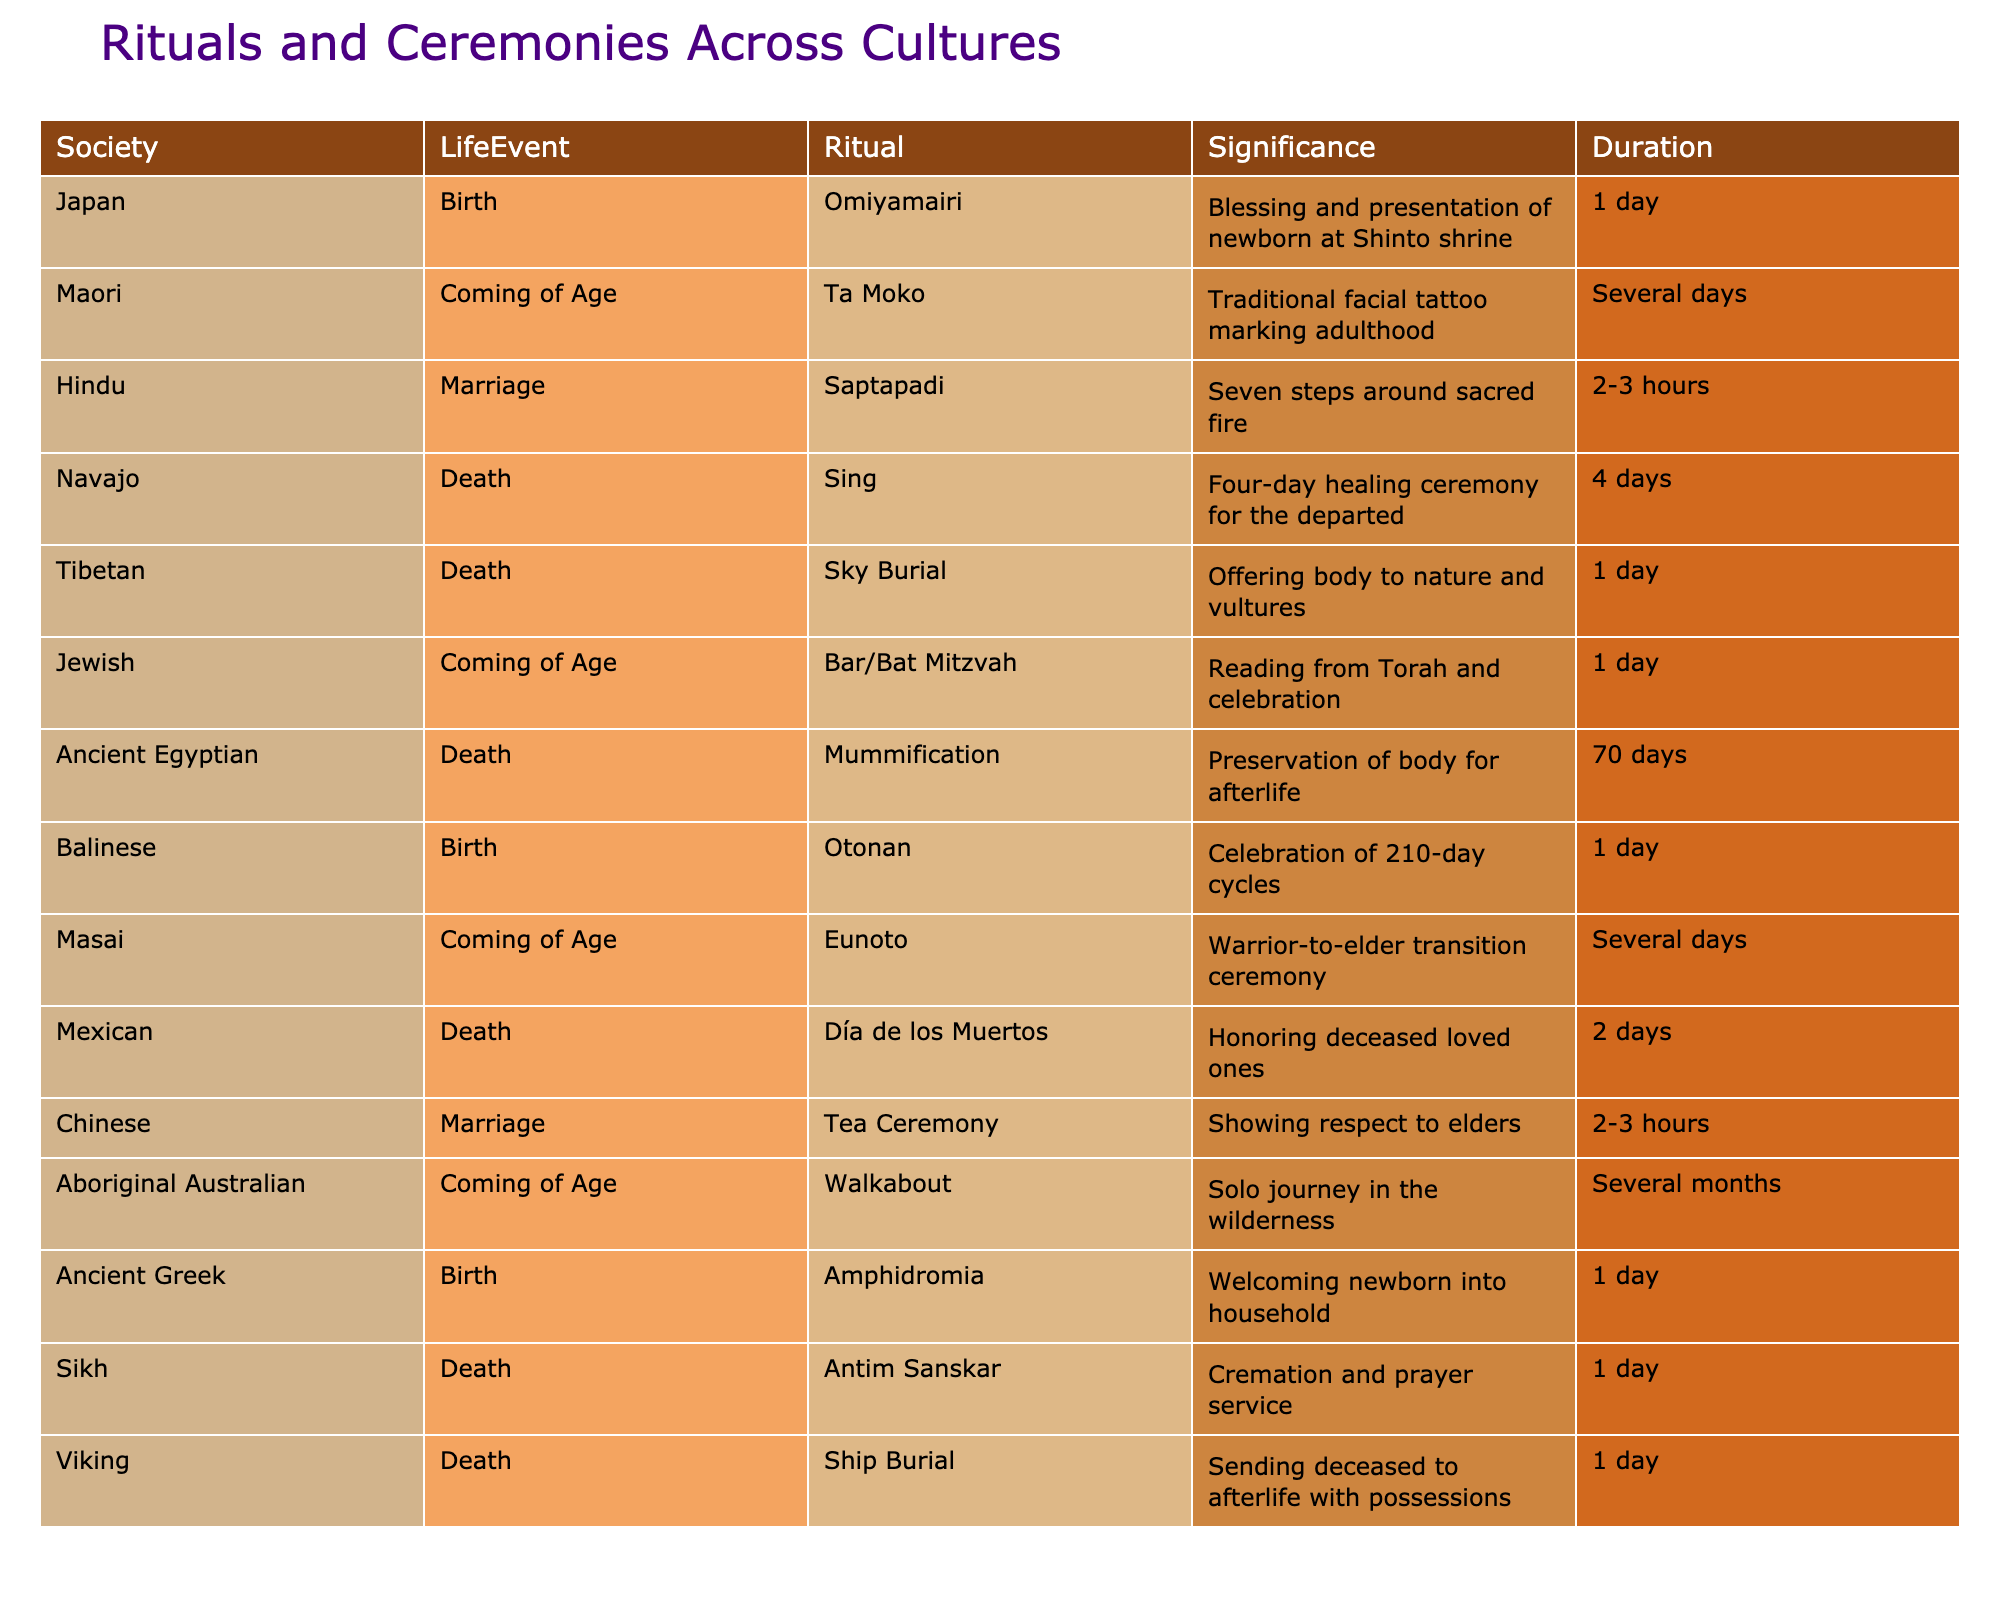What ritual is associated with death in Navajo culture? The table lists "Sing" as the ritual for death in Navajo culture.
Answer: Sing How long does the mummification process take in Ancient Egypt? The table indicates that mummification takes 70 days in Ancient Egypt.
Answer: 70 days Which societies have a coming-of-age ritual that lasts several days? Referring to the table, the Maori, Masai, and Aboriginal Australian societies have coming-of-age rituals that last several days.
Answer: Maori, Masai, and Aboriginal Australian What is the average duration of rituals associated with birth in the listed societies? The birth rituals are Omiyamairi (1 day), Otonan (1 day), and Amphidromia (1 day). Summing these values gives 3 days, and dividing by 3 (the number of rituals) gives an average of 1 day.
Answer: 1 day Is the tea ceremony in Chinese culture related to marriage? The table confirms that the tea ceremony is associated with marriage in Chinese culture, so the answer is yes.
Answer: Yes What signifies the seven steps taken around the sacred fire in Hindu marriage rituals? The table explains that the Saptapadi, or seven steps, represents a significant commitment in marriage in Hindu culture.
Answer: Commitment in marriage Which society practices a four-day healing ceremony for the departed? According to the table, the Navajo society practices a four-day healing ceremony known as "Sing" for the departed.
Answer: Navajo Are there any societies that have rituals last longer than a week for coming of age? The Aboriginal Australian society has a walkabout that lasts several months, which is longer than a week.
Answer: Yes What is the significance of the traditional facial tattoo Ta Moko among the Maori? The significance of Ta Moko, as per the table, is marking adulthood in Maori culture.
Answer: Marking adulthood Which life event associated with death involves offering the body to nature in Tibetan culture? The table lists "Sky Burial" as the ritual in Tibetan culture that involves offering the body to nature.
Answer: Sky Burial If you combine the durations of the rituals for death from Sikh and Viking cultures, what is the total duration? The Sikh death ritual (Antim Sanskar) takes 1 day and the Viking ritual (Ship Burial) also takes 1 day. Adding these together gives a total duration of 2 days.
Answer: 2 days 